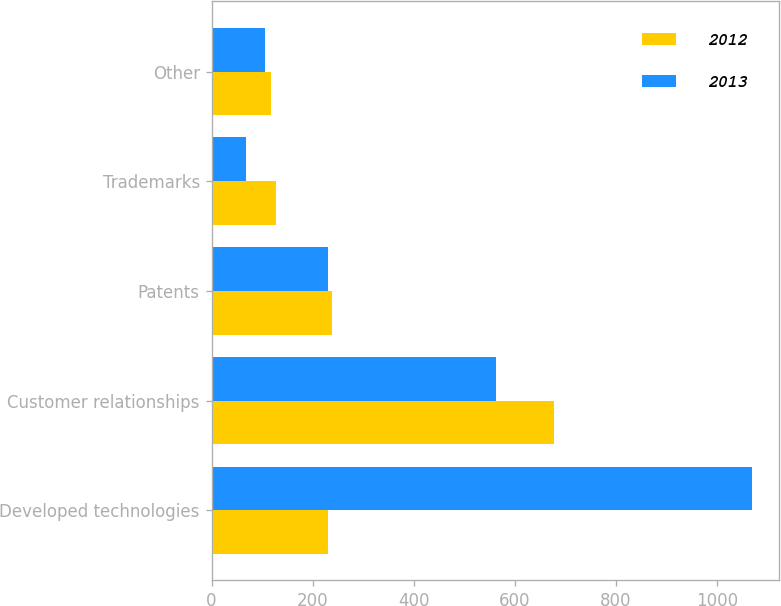Convert chart to OTSL. <chart><loc_0><loc_0><loc_500><loc_500><stacked_bar_chart><ecel><fcel>Developed technologies<fcel>Customer relationships<fcel>Patents<fcel>Trademarks<fcel>Other<nl><fcel>2012<fcel>230<fcel>677<fcel>238<fcel>127<fcel>118<nl><fcel>2013<fcel>1069<fcel>563<fcel>230<fcel>69<fcel>105<nl></chart> 